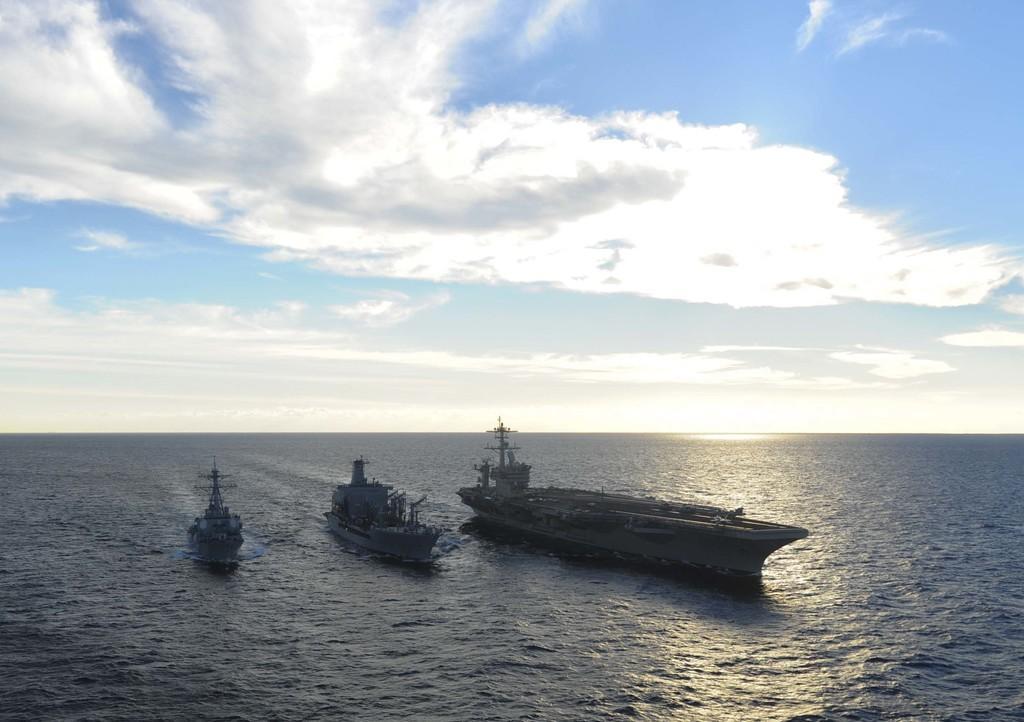How would you summarize this image in a sentence or two? In this image, we can see ships on the water and at the top, there are clouds in the sky. 